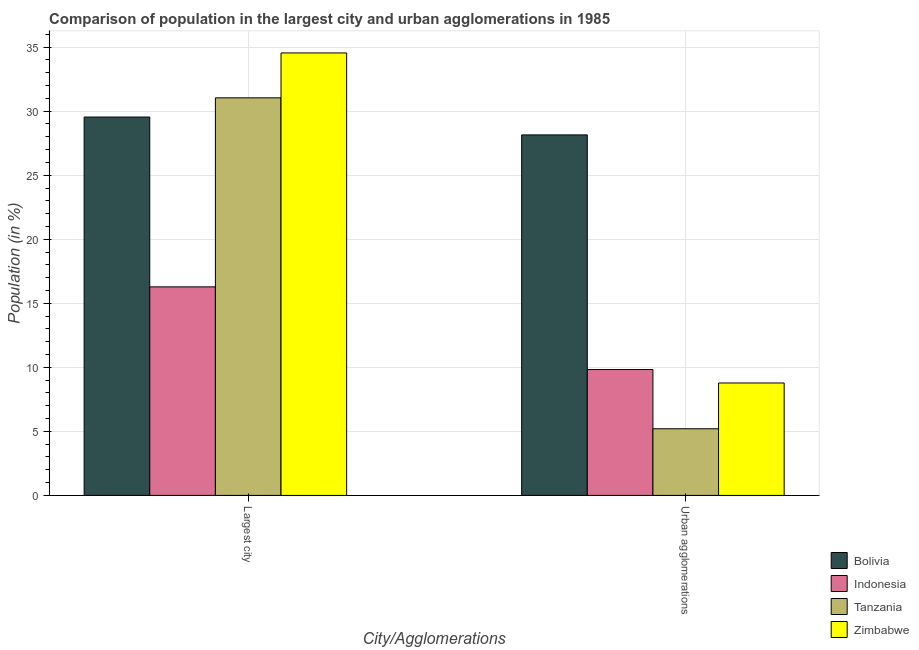How many different coloured bars are there?
Make the answer very short. 4. Are the number of bars per tick equal to the number of legend labels?
Provide a short and direct response. Yes. Are the number of bars on each tick of the X-axis equal?
Keep it short and to the point. Yes. How many bars are there on the 2nd tick from the left?
Make the answer very short. 4. What is the label of the 2nd group of bars from the left?
Provide a short and direct response. Urban agglomerations. What is the population in the largest city in Bolivia?
Provide a succinct answer. 29.54. Across all countries, what is the maximum population in urban agglomerations?
Your response must be concise. 28.15. Across all countries, what is the minimum population in the largest city?
Make the answer very short. 16.28. In which country was the population in the largest city maximum?
Ensure brevity in your answer.  Zimbabwe. In which country was the population in the largest city minimum?
Ensure brevity in your answer.  Indonesia. What is the total population in urban agglomerations in the graph?
Provide a short and direct response. 51.96. What is the difference between the population in the largest city in Tanzania and that in Indonesia?
Provide a succinct answer. 14.76. What is the difference between the population in the largest city in Zimbabwe and the population in urban agglomerations in Tanzania?
Offer a terse response. 29.34. What is the average population in the largest city per country?
Keep it short and to the point. 27.85. What is the difference between the population in the largest city and population in urban agglomerations in Tanzania?
Your answer should be compact. 25.83. What is the ratio of the population in the largest city in Indonesia to that in Zimbabwe?
Ensure brevity in your answer.  0.47. What does the 4th bar from the left in Largest city represents?
Your response must be concise. Zimbabwe. Does the graph contain grids?
Your response must be concise. Yes. Where does the legend appear in the graph?
Provide a succinct answer. Bottom right. What is the title of the graph?
Provide a succinct answer. Comparison of population in the largest city and urban agglomerations in 1985. What is the label or title of the X-axis?
Ensure brevity in your answer.  City/Agglomerations. What is the Population (in %) of Bolivia in Largest city?
Offer a terse response. 29.54. What is the Population (in %) in Indonesia in Largest city?
Ensure brevity in your answer.  16.28. What is the Population (in %) of Tanzania in Largest city?
Provide a short and direct response. 31.04. What is the Population (in %) in Zimbabwe in Largest city?
Offer a terse response. 34.54. What is the Population (in %) of Bolivia in Urban agglomerations?
Your answer should be compact. 28.15. What is the Population (in %) of Indonesia in Urban agglomerations?
Keep it short and to the point. 9.83. What is the Population (in %) in Tanzania in Urban agglomerations?
Your response must be concise. 5.2. What is the Population (in %) in Zimbabwe in Urban agglomerations?
Keep it short and to the point. 8.78. Across all City/Agglomerations, what is the maximum Population (in %) of Bolivia?
Give a very brief answer. 29.54. Across all City/Agglomerations, what is the maximum Population (in %) in Indonesia?
Keep it short and to the point. 16.28. Across all City/Agglomerations, what is the maximum Population (in %) in Tanzania?
Give a very brief answer. 31.04. Across all City/Agglomerations, what is the maximum Population (in %) in Zimbabwe?
Your response must be concise. 34.54. Across all City/Agglomerations, what is the minimum Population (in %) of Bolivia?
Ensure brevity in your answer.  28.15. Across all City/Agglomerations, what is the minimum Population (in %) in Indonesia?
Your answer should be very brief. 9.83. Across all City/Agglomerations, what is the minimum Population (in %) of Tanzania?
Offer a terse response. 5.2. Across all City/Agglomerations, what is the minimum Population (in %) of Zimbabwe?
Your response must be concise. 8.78. What is the total Population (in %) of Bolivia in the graph?
Keep it short and to the point. 57.68. What is the total Population (in %) in Indonesia in the graph?
Ensure brevity in your answer.  26.11. What is the total Population (in %) of Tanzania in the graph?
Ensure brevity in your answer.  36.24. What is the total Population (in %) of Zimbabwe in the graph?
Provide a short and direct response. 43.32. What is the difference between the Population (in %) of Bolivia in Largest city and that in Urban agglomerations?
Provide a short and direct response. 1.39. What is the difference between the Population (in %) of Indonesia in Largest city and that in Urban agglomerations?
Keep it short and to the point. 6.45. What is the difference between the Population (in %) in Tanzania in Largest city and that in Urban agglomerations?
Offer a very short reply. 25.83. What is the difference between the Population (in %) of Zimbabwe in Largest city and that in Urban agglomerations?
Provide a succinct answer. 25.76. What is the difference between the Population (in %) of Bolivia in Largest city and the Population (in %) of Indonesia in Urban agglomerations?
Your answer should be very brief. 19.71. What is the difference between the Population (in %) of Bolivia in Largest city and the Population (in %) of Tanzania in Urban agglomerations?
Give a very brief answer. 24.34. What is the difference between the Population (in %) of Bolivia in Largest city and the Population (in %) of Zimbabwe in Urban agglomerations?
Offer a very short reply. 20.76. What is the difference between the Population (in %) of Indonesia in Largest city and the Population (in %) of Tanzania in Urban agglomerations?
Keep it short and to the point. 11.08. What is the difference between the Population (in %) of Indonesia in Largest city and the Population (in %) of Zimbabwe in Urban agglomerations?
Your response must be concise. 7.5. What is the difference between the Population (in %) of Tanzania in Largest city and the Population (in %) of Zimbabwe in Urban agglomerations?
Offer a terse response. 22.26. What is the average Population (in %) of Bolivia per City/Agglomerations?
Offer a very short reply. 28.84. What is the average Population (in %) in Indonesia per City/Agglomerations?
Provide a succinct answer. 13.05. What is the average Population (in %) of Tanzania per City/Agglomerations?
Your answer should be very brief. 18.12. What is the average Population (in %) in Zimbabwe per City/Agglomerations?
Offer a very short reply. 21.66. What is the difference between the Population (in %) in Bolivia and Population (in %) in Indonesia in Largest city?
Keep it short and to the point. 13.26. What is the difference between the Population (in %) of Bolivia and Population (in %) of Tanzania in Largest city?
Keep it short and to the point. -1.5. What is the difference between the Population (in %) of Bolivia and Population (in %) of Zimbabwe in Largest city?
Provide a succinct answer. -5. What is the difference between the Population (in %) of Indonesia and Population (in %) of Tanzania in Largest city?
Offer a very short reply. -14.76. What is the difference between the Population (in %) in Indonesia and Population (in %) in Zimbabwe in Largest city?
Your answer should be very brief. -18.26. What is the difference between the Population (in %) in Tanzania and Population (in %) in Zimbabwe in Largest city?
Ensure brevity in your answer.  -3.5. What is the difference between the Population (in %) in Bolivia and Population (in %) in Indonesia in Urban agglomerations?
Offer a very short reply. 18.32. What is the difference between the Population (in %) of Bolivia and Population (in %) of Tanzania in Urban agglomerations?
Provide a succinct answer. 22.94. What is the difference between the Population (in %) in Bolivia and Population (in %) in Zimbabwe in Urban agglomerations?
Give a very brief answer. 19.37. What is the difference between the Population (in %) of Indonesia and Population (in %) of Tanzania in Urban agglomerations?
Offer a terse response. 4.62. What is the difference between the Population (in %) of Indonesia and Population (in %) of Zimbabwe in Urban agglomerations?
Your answer should be very brief. 1.05. What is the difference between the Population (in %) in Tanzania and Population (in %) in Zimbabwe in Urban agglomerations?
Your answer should be compact. -3.57. What is the ratio of the Population (in %) of Bolivia in Largest city to that in Urban agglomerations?
Offer a very short reply. 1.05. What is the ratio of the Population (in %) in Indonesia in Largest city to that in Urban agglomerations?
Provide a succinct answer. 1.66. What is the ratio of the Population (in %) in Tanzania in Largest city to that in Urban agglomerations?
Provide a succinct answer. 5.96. What is the ratio of the Population (in %) of Zimbabwe in Largest city to that in Urban agglomerations?
Ensure brevity in your answer.  3.93. What is the difference between the highest and the second highest Population (in %) of Bolivia?
Your answer should be very brief. 1.39. What is the difference between the highest and the second highest Population (in %) in Indonesia?
Offer a terse response. 6.45. What is the difference between the highest and the second highest Population (in %) in Tanzania?
Your answer should be compact. 25.83. What is the difference between the highest and the second highest Population (in %) of Zimbabwe?
Provide a short and direct response. 25.76. What is the difference between the highest and the lowest Population (in %) of Bolivia?
Your answer should be very brief. 1.39. What is the difference between the highest and the lowest Population (in %) in Indonesia?
Ensure brevity in your answer.  6.45. What is the difference between the highest and the lowest Population (in %) of Tanzania?
Your response must be concise. 25.83. What is the difference between the highest and the lowest Population (in %) in Zimbabwe?
Make the answer very short. 25.76. 